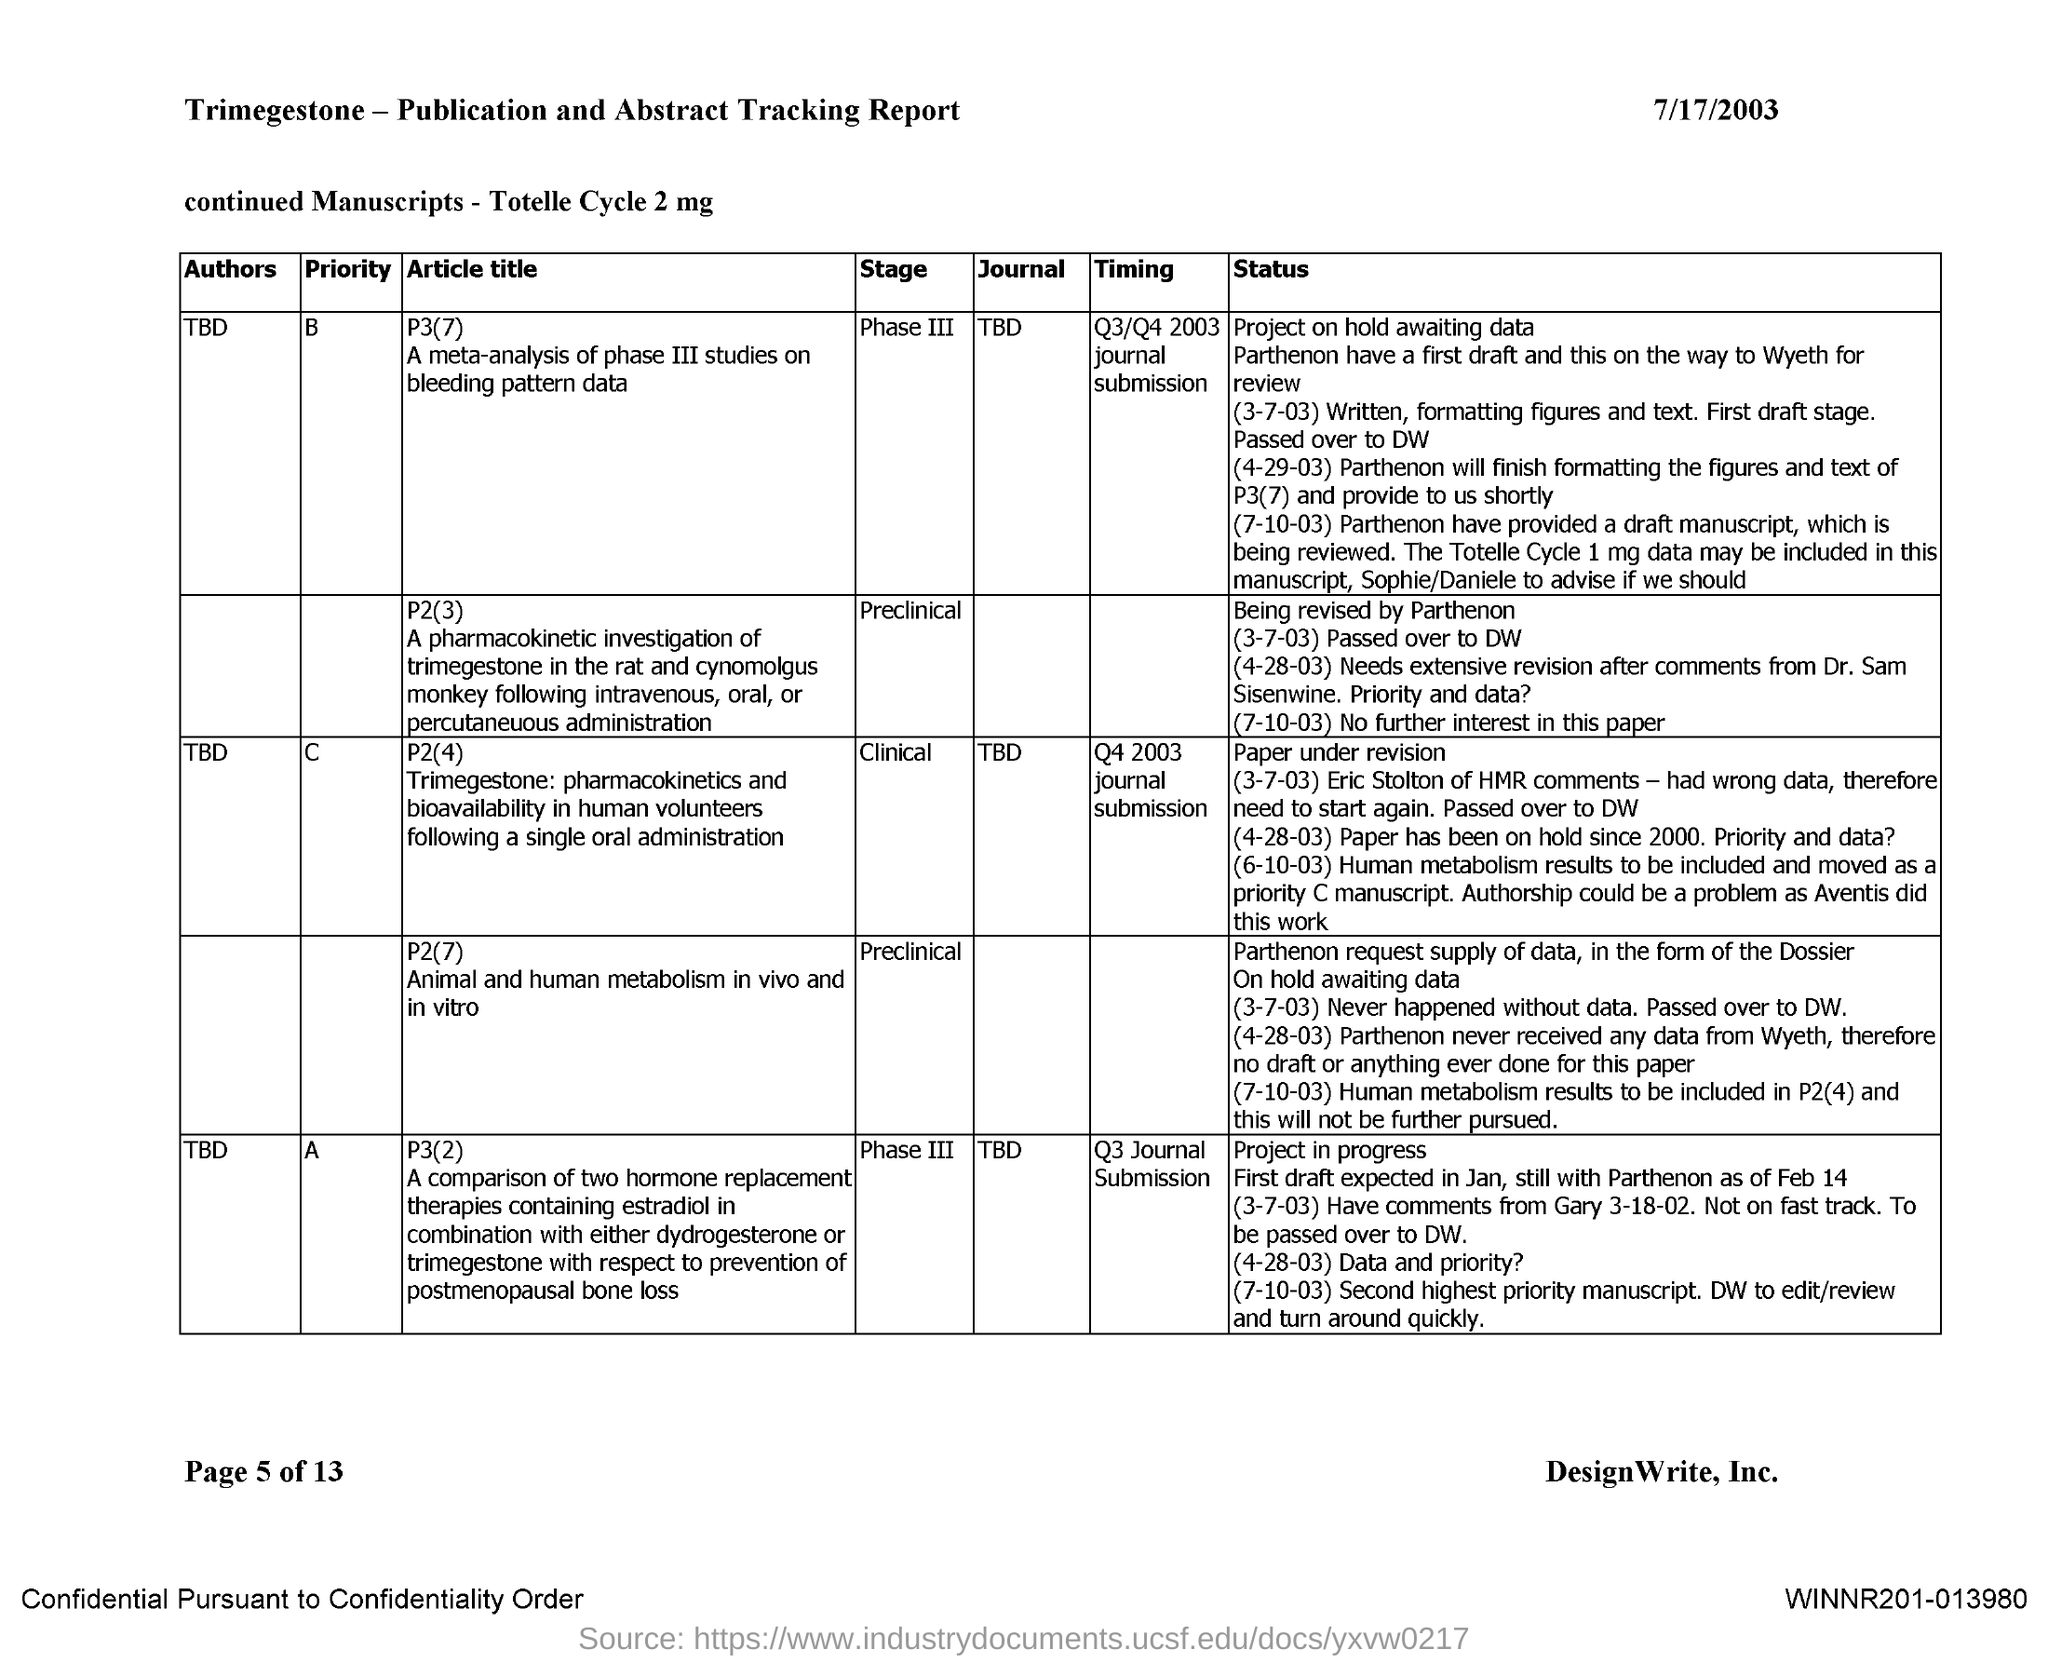What is the date mentioned in the document?
Ensure brevity in your answer.  7/17/2003. Who is the author of the journal TBD with priority "B"?
Your answer should be very brief. TBD. Who is the author of the journal TBD with priority "C"?
Keep it short and to the point. TBD. Who is the author of the journal TBD with priority "A"?
Provide a succinct answer. TBD. What is the name of the journal with priority "B"?
Your answer should be very brief. TBD. 